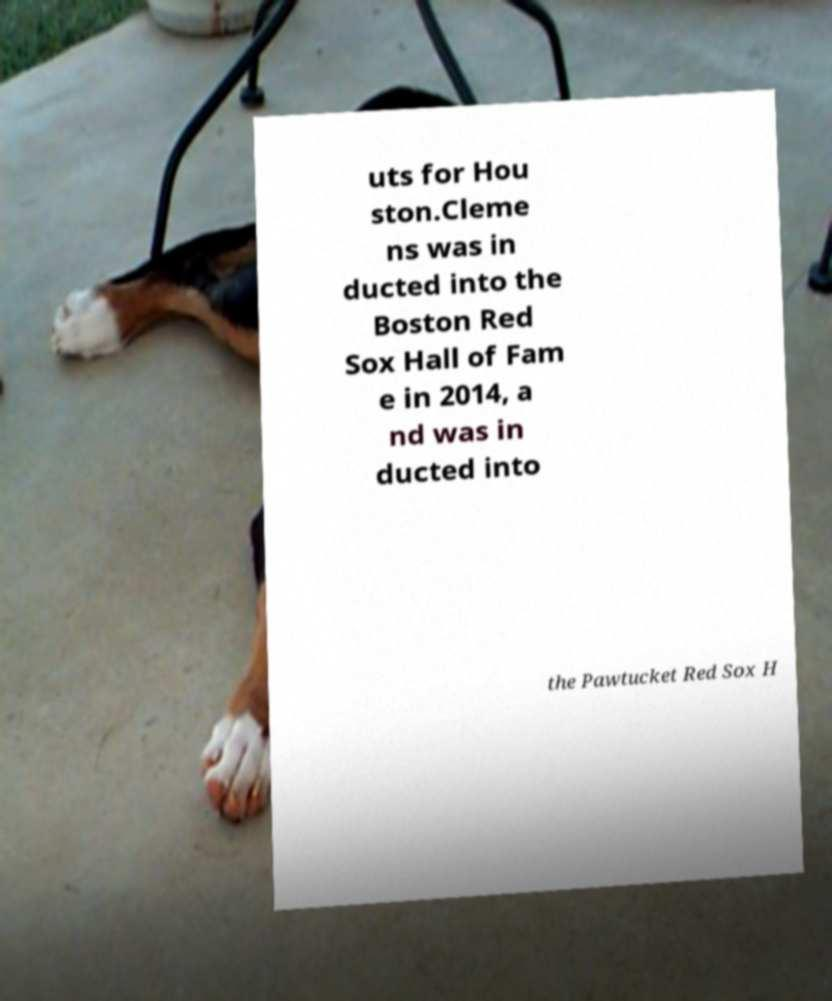What messages or text are displayed in this image? I need them in a readable, typed format. uts for Hou ston.Cleme ns was in ducted into the Boston Red Sox Hall of Fam e in 2014, a nd was in ducted into the Pawtucket Red Sox H 